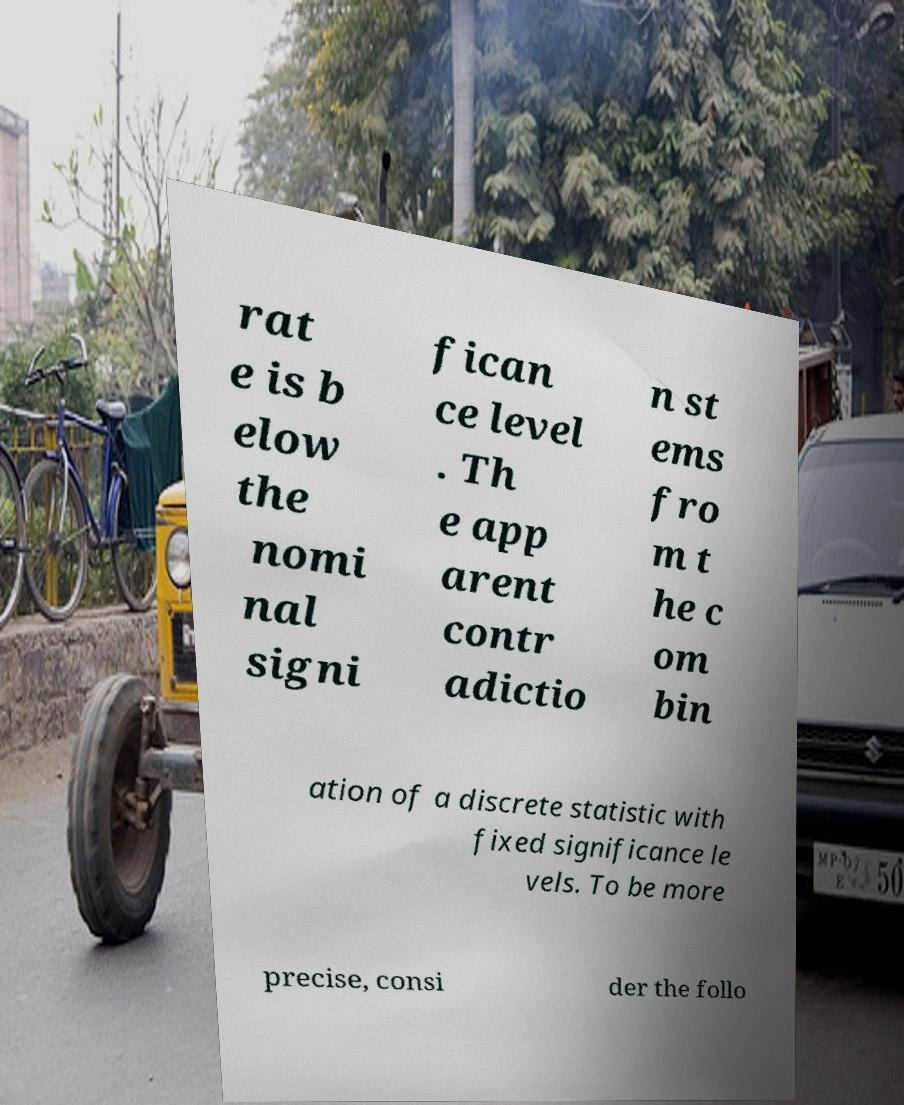What messages or text are displayed in this image? I need them in a readable, typed format. rat e is b elow the nomi nal signi fican ce level . Th e app arent contr adictio n st ems fro m t he c om bin ation of a discrete statistic with fixed significance le vels. To be more precise, consi der the follo 